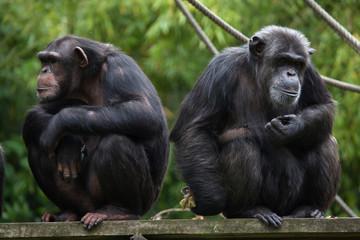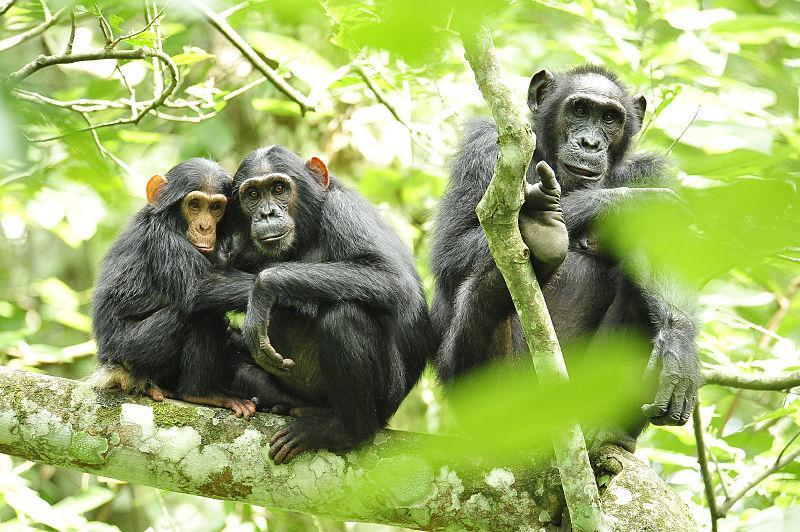The first image is the image on the left, the second image is the image on the right. Assess this claim about the two images: "At least three primates are huddled in the image on the right.". Correct or not? Answer yes or no. Yes. The first image is the image on the left, the second image is the image on the right. Considering the images on both sides, is "An image shows an adult chimp in sleeping pose with its head on the left, and a smaller chimp near it." valid? Answer yes or no. No. 